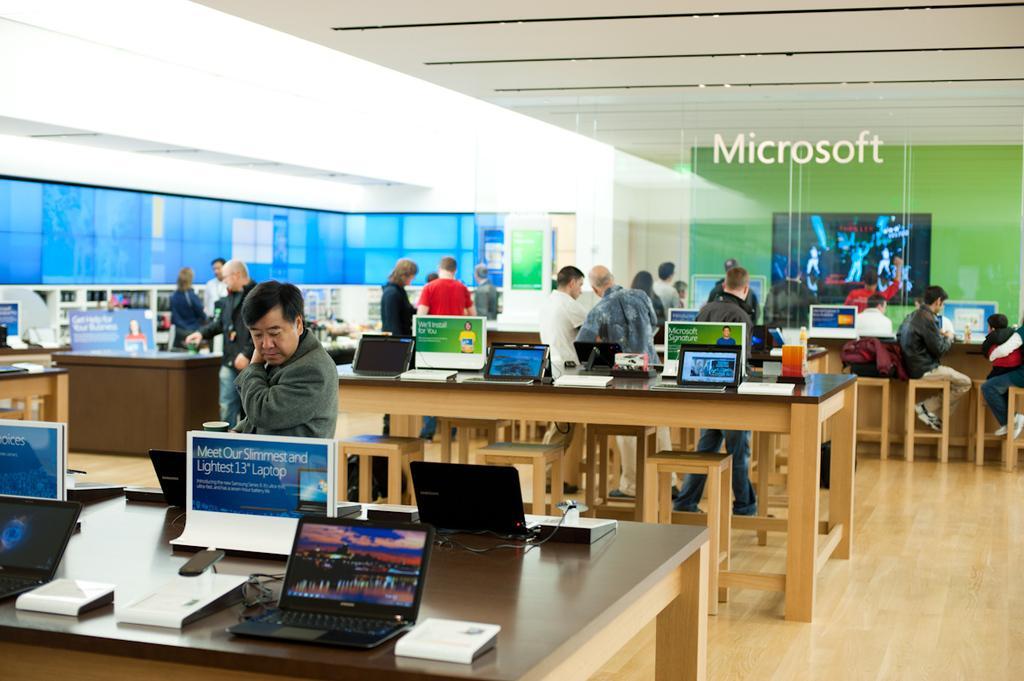Could you give a brief overview of what you see in this image? In this image we can see many laptops are placed on the table and this people are standing near the table. 